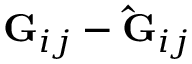Convert formula to latex. <formula><loc_0><loc_0><loc_500><loc_500>G _ { i j } - \hat { G } _ { i j }</formula> 